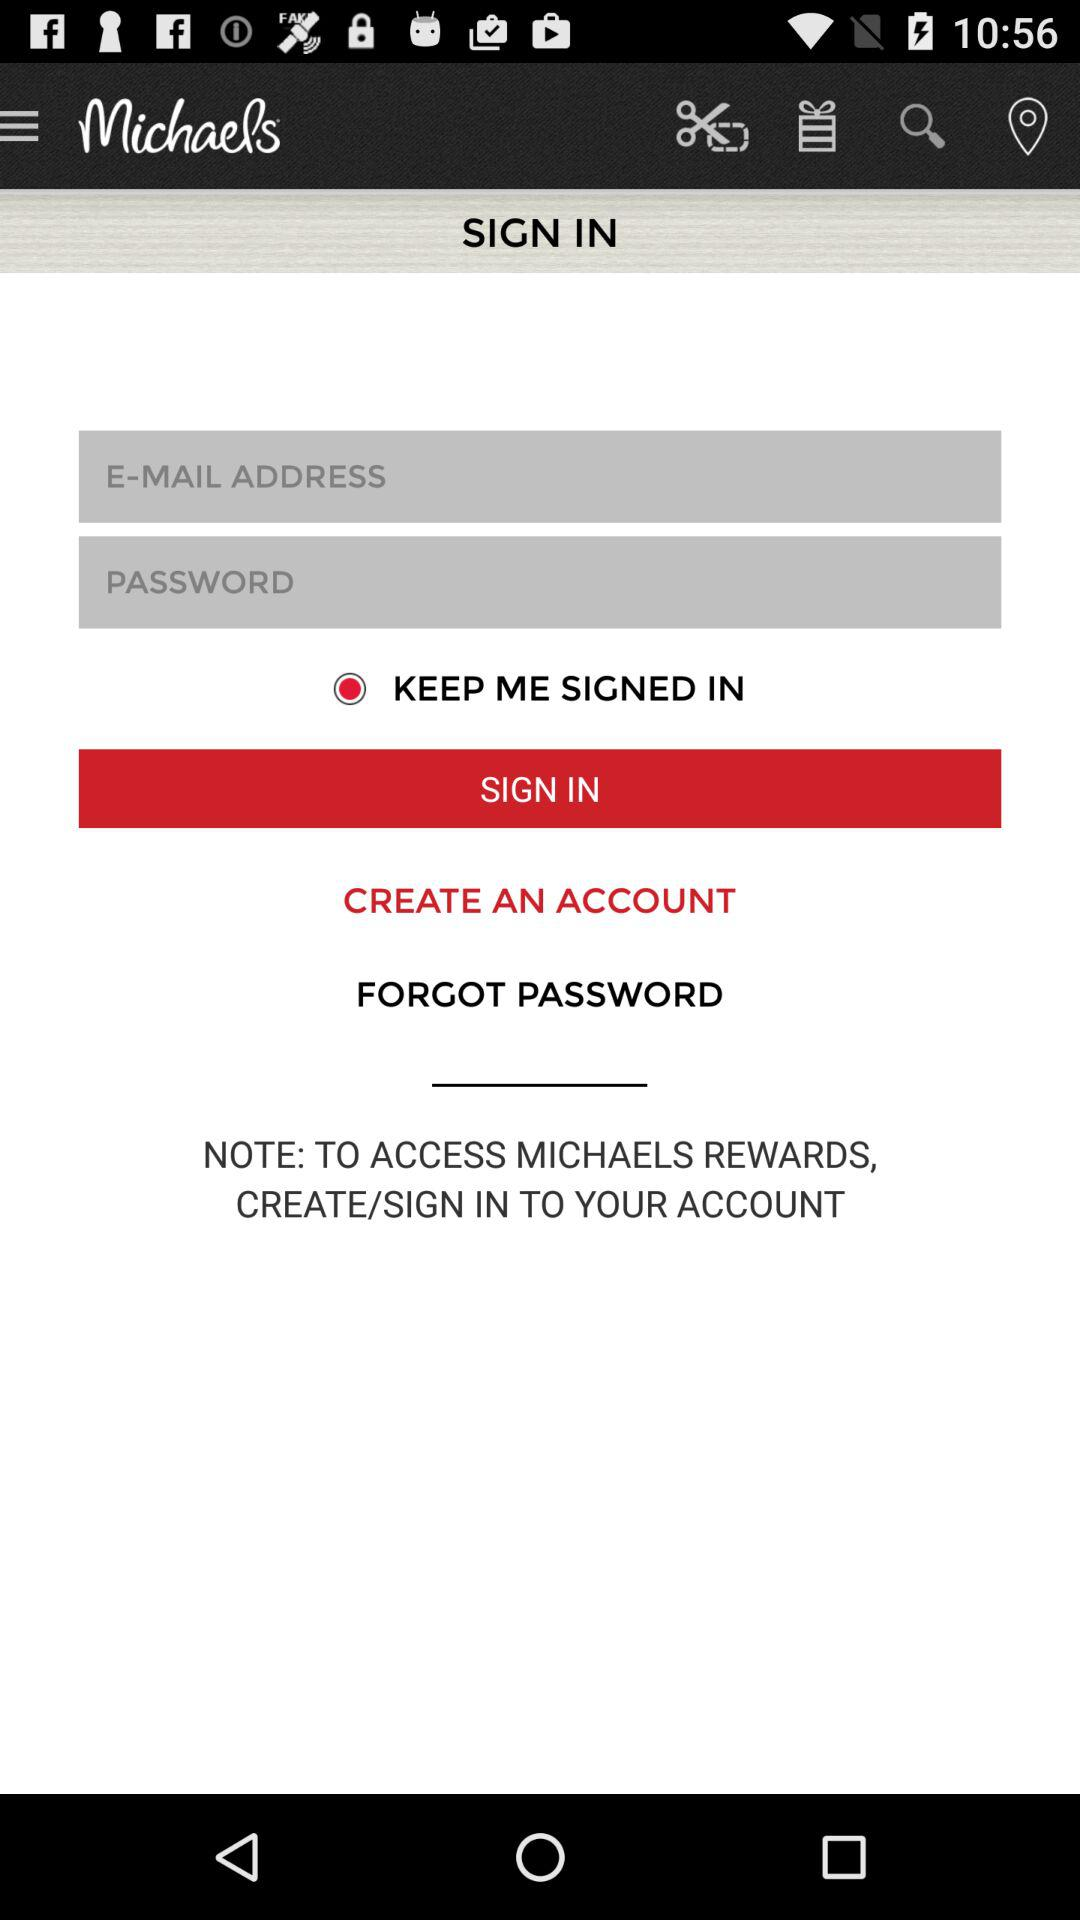What is the status of the "KEEP ME SIGNED IN"? The status of the "KEEP ME SIGNED IN" is "on". 